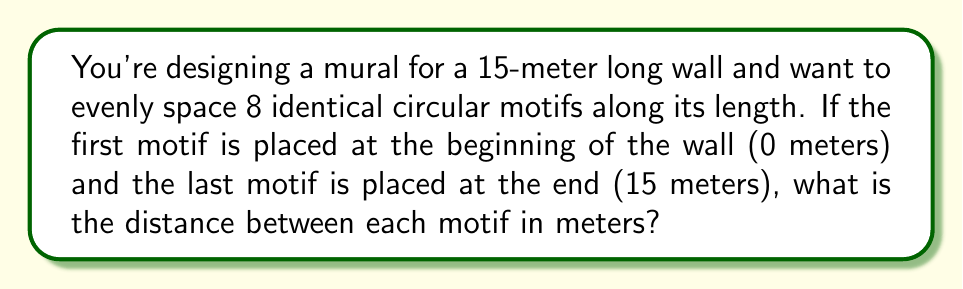Provide a solution to this math problem. Let's approach this step-by-step:

1) First, we need to understand what we're calculating. We're looking for the spacing between motifs, which is the same as the distance between any two adjacent motifs.

2) We have 8 motifs in total. This means there are 7 spaces between motifs.

3) The total length of the wall is 15 meters.

4) We can set up an equation:
   $$(7 \times \text{spacing}) + \text{width of motifs} = 15$$

5) Since the motifs are placed at the very beginning and end of the wall, we don't need to account for their width in our calculation.

6) Our equation simplifies to:
   $$7x = 15$$
   Where $x$ is the spacing we're looking for.

7) Solving for $x$:
   $$x = \frac{15}{7} \approx 2.1428571429$$

8) Therefore, the spacing between each motif is $\frac{15}{7}$ meters or approximately 2.14 meters.

To verify:
$$7 \times \frac{15}{7} = 15$$

This confirms that 7 spaces of $\frac{15}{7}$ meters each will indeed span the entire 15-meter wall.
Answer: $\frac{15}{7}$ meters 